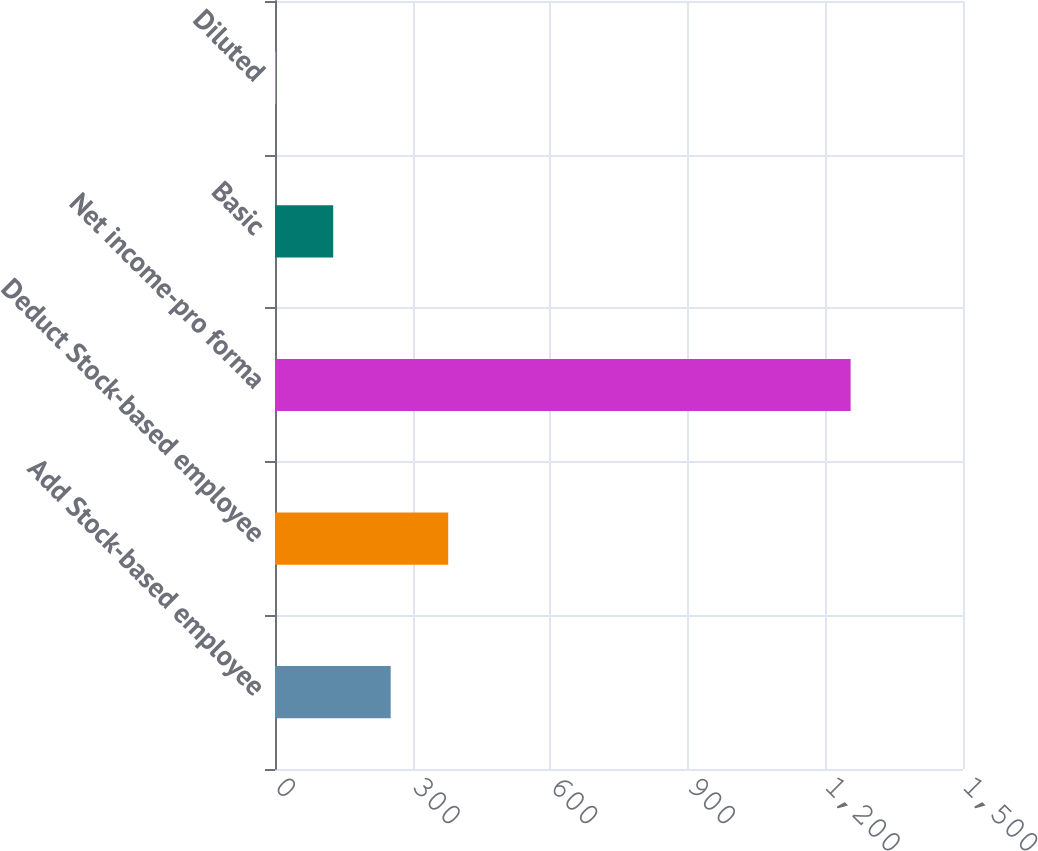Convert chart to OTSL. <chart><loc_0><loc_0><loc_500><loc_500><bar_chart><fcel>Add Stock-based employee<fcel>Deduct Stock-based employee<fcel>Net income-pro forma<fcel>Basic<fcel>Diluted<nl><fcel>252.25<fcel>377.6<fcel>1255<fcel>126.9<fcel>1.55<nl></chart> 